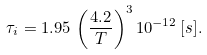Convert formula to latex. <formula><loc_0><loc_0><loc_500><loc_500>\tau _ { i } = 1 . 9 5 \, \left ( \frac { 4 . 2 } { T } \right ) ^ { 3 } 1 0 ^ { - 1 2 } \, [ s ] .</formula> 